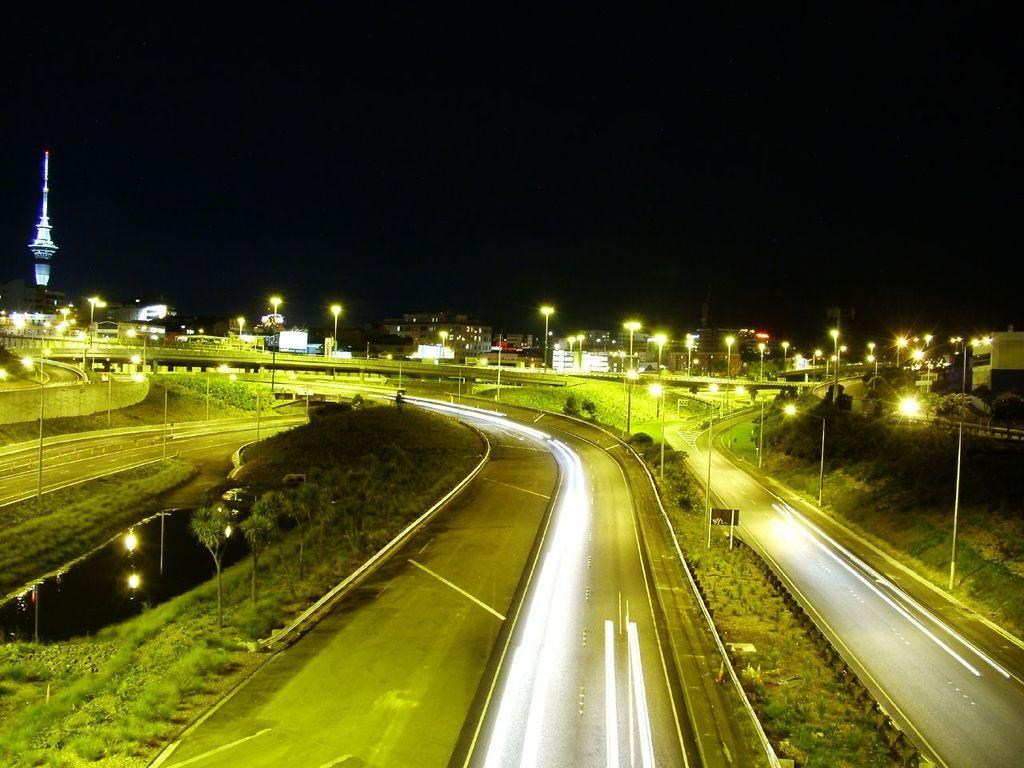Could you give a brief overview of what you see in this image? There is a road, trees and a grassy land at the bottom of this image. We can see bridge, lights and buildings in the middle of this image. It is dark at the top of this image. 